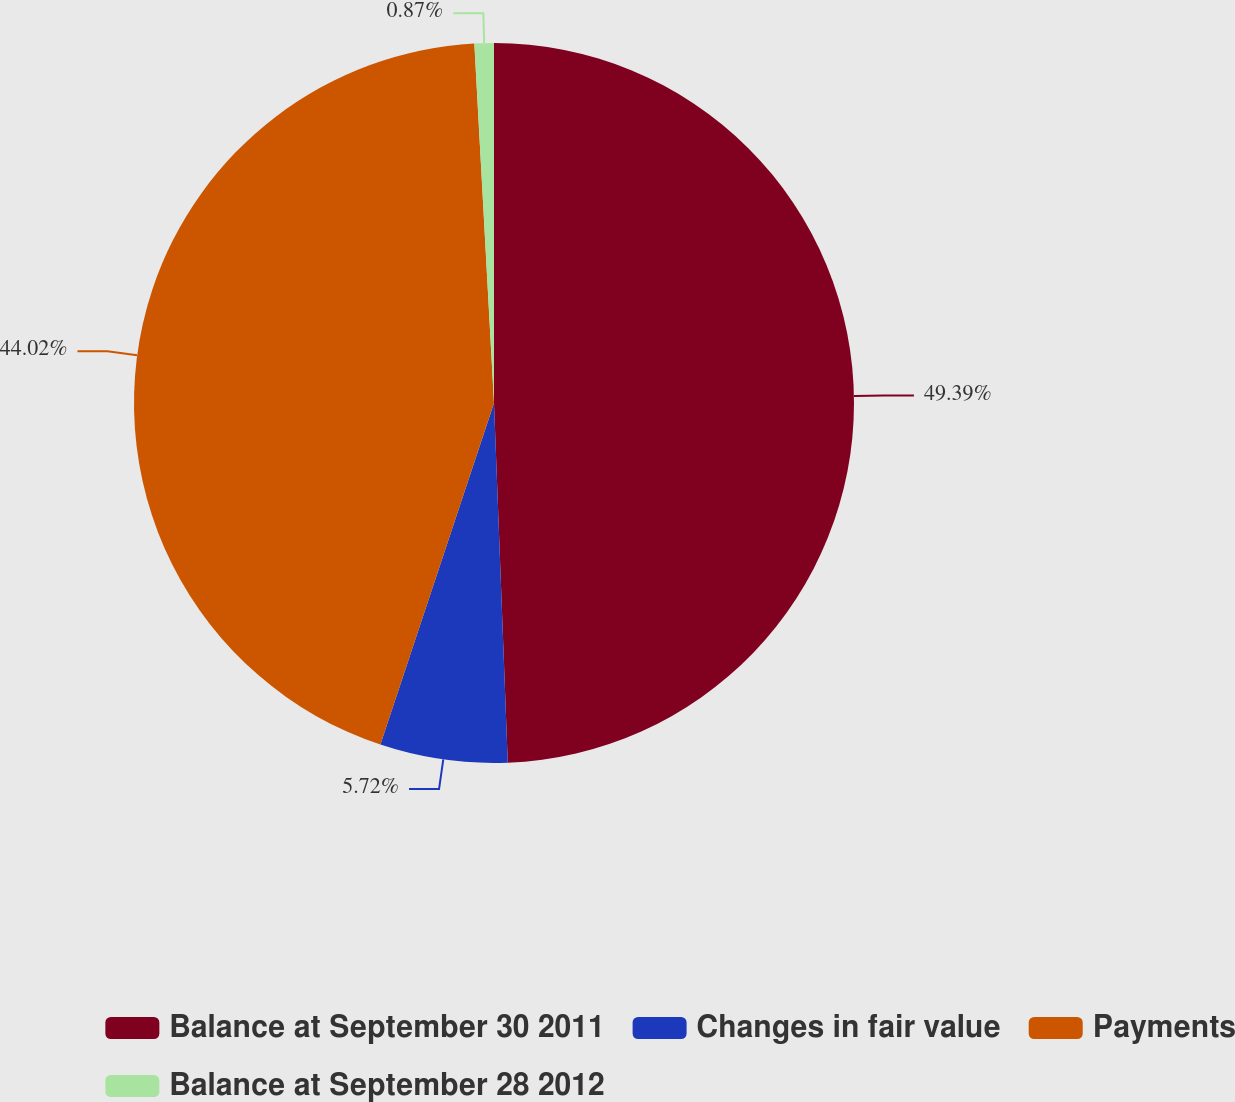<chart> <loc_0><loc_0><loc_500><loc_500><pie_chart><fcel>Balance at September 30 2011<fcel>Changes in fair value<fcel>Payments<fcel>Balance at September 28 2012<nl><fcel>49.39%<fcel>5.72%<fcel>44.02%<fcel>0.87%<nl></chart> 